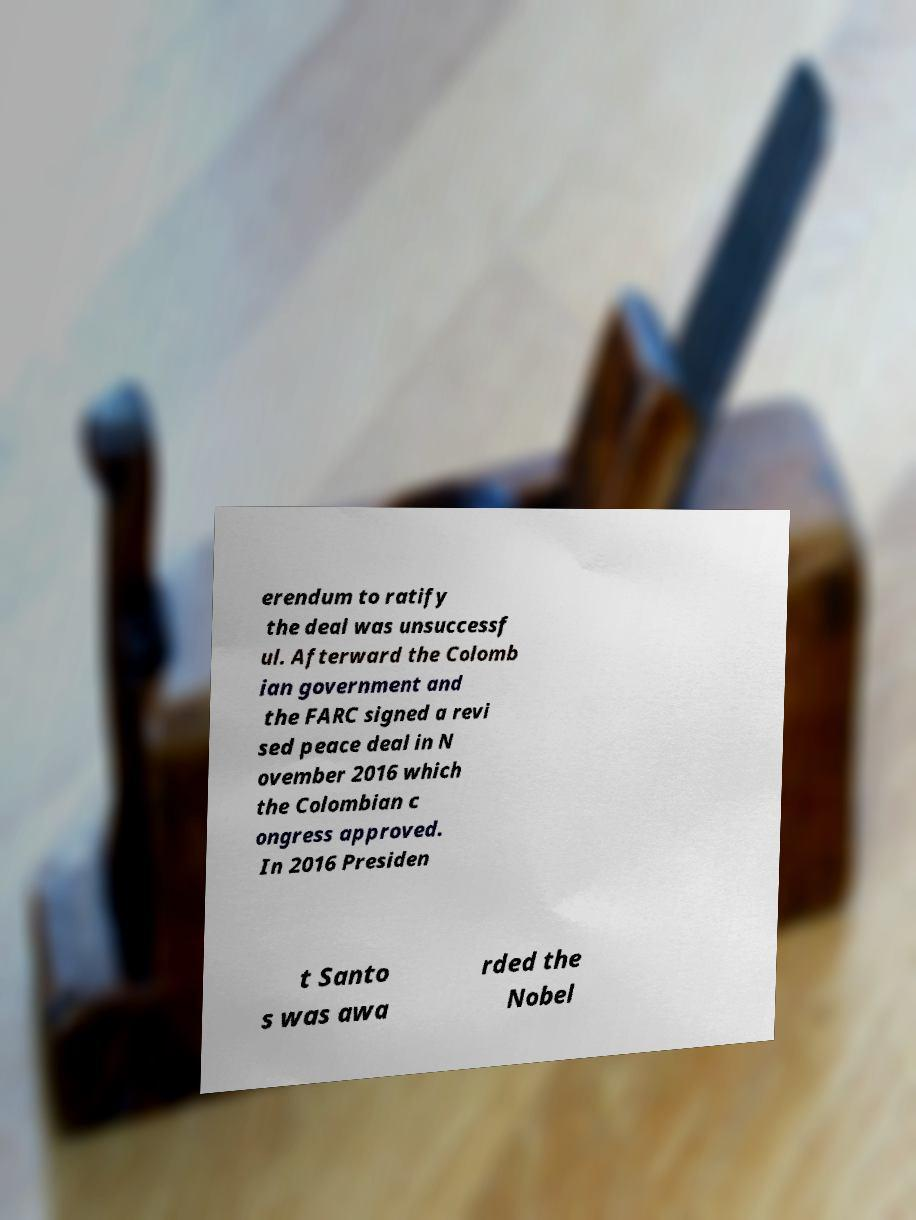Can you read and provide the text displayed in the image?This photo seems to have some interesting text. Can you extract and type it out for me? erendum to ratify the deal was unsuccessf ul. Afterward the Colomb ian government and the FARC signed a revi sed peace deal in N ovember 2016 which the Colombian c ongress approved. In 2016 Presiden t Santo s was awa rded the Nobel 